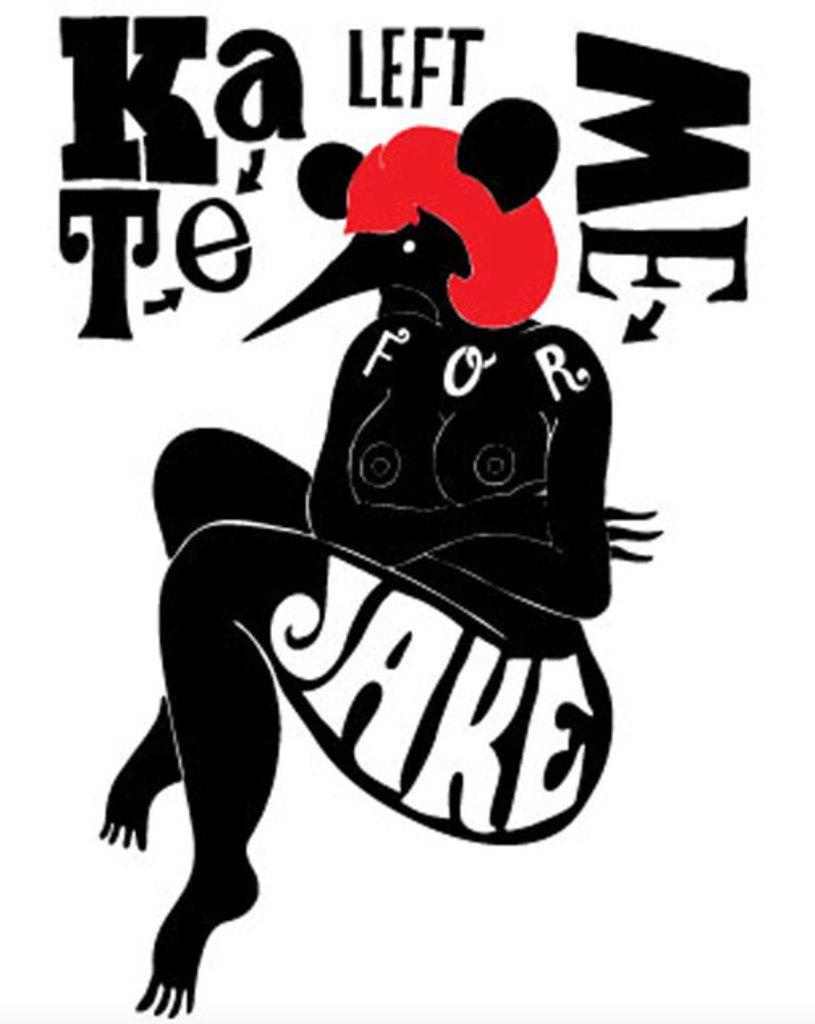Please provide a concise description of this image. This is an animated human image with some text. 